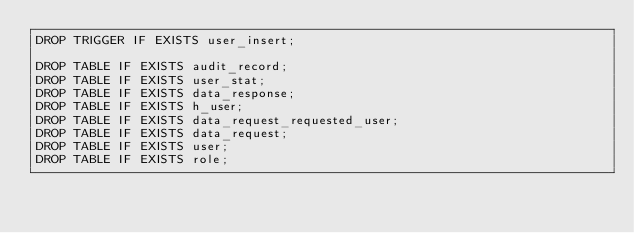Convert code to text. <code><loc_0><loc_0><loc_500><loc_500><_SQL_>DROP TRIGGER IF EXISTS user_insert;

DROP TABLE IF EXISTS audit_record;
DROP TABLE IF EXISTS user_stat;
DROP TABLE IF EXISTS data_response;
DROP TABLE IF EXISTS h_user;
DROP TABLE IF EXISTS data_request_requested_user;
DROP TABLE IF EXISTS data_request;
DROP TABLE IF EXISTS user;
DROP TABLE IF EXISTS role;</code> 